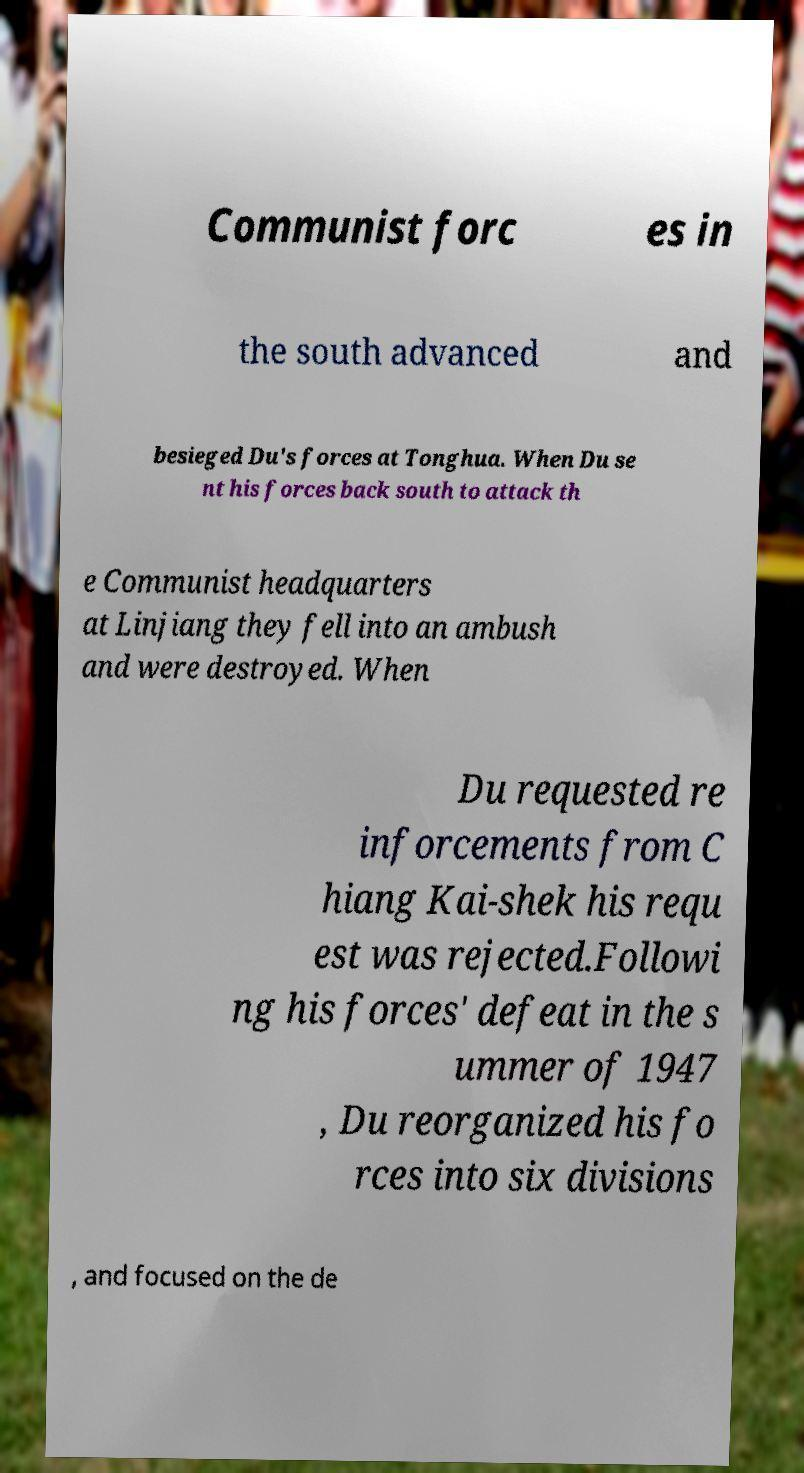What messages or text are displayed in this image? I need them in a readable, typed format. Communist forc es in the south advanced and besieged Du's forces at Tonghua. When Du se nt his forces back south to attack th e Communist headquarters at Linjiang they fell into an ambush and were destroyed. When Du requested re inforcements from C hiang Kai-shek his requ est was rejected.Followi ng his forces' defeat in the s ummer of 1947 , Du reorganized his fo rces into six divisions , and focused on the de 